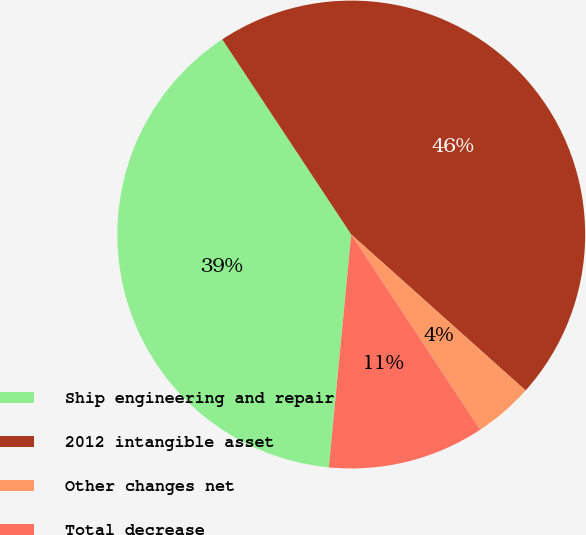<chart> <loc_0><loc_0><loc_500><loc_500><pie_chart><fcel>Ship engineering and repair<fcel>2012 intangible asset<fcel>Other changes net<fcel>Total decrease<nl><fcel>39.18%<fcel>45.91%<fcel>4.09%<fcel>10.82%<nl></chart> 